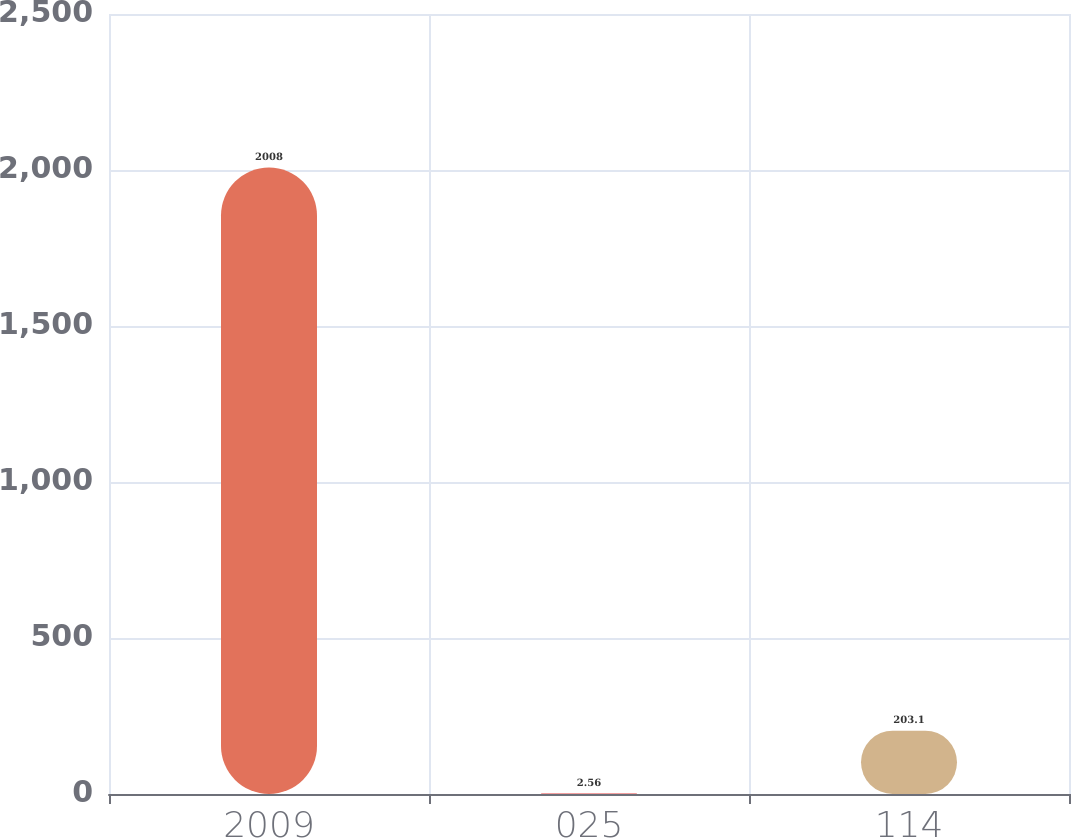Convert chart to OTSL. <chart><loc_0><loc_0><loc_500><loc_500><bar_chart><fcel>2009<fcel>025<fcel>114<nl><fcel>2008<fcel>2.56<fcel>203.1<nl></chart> 